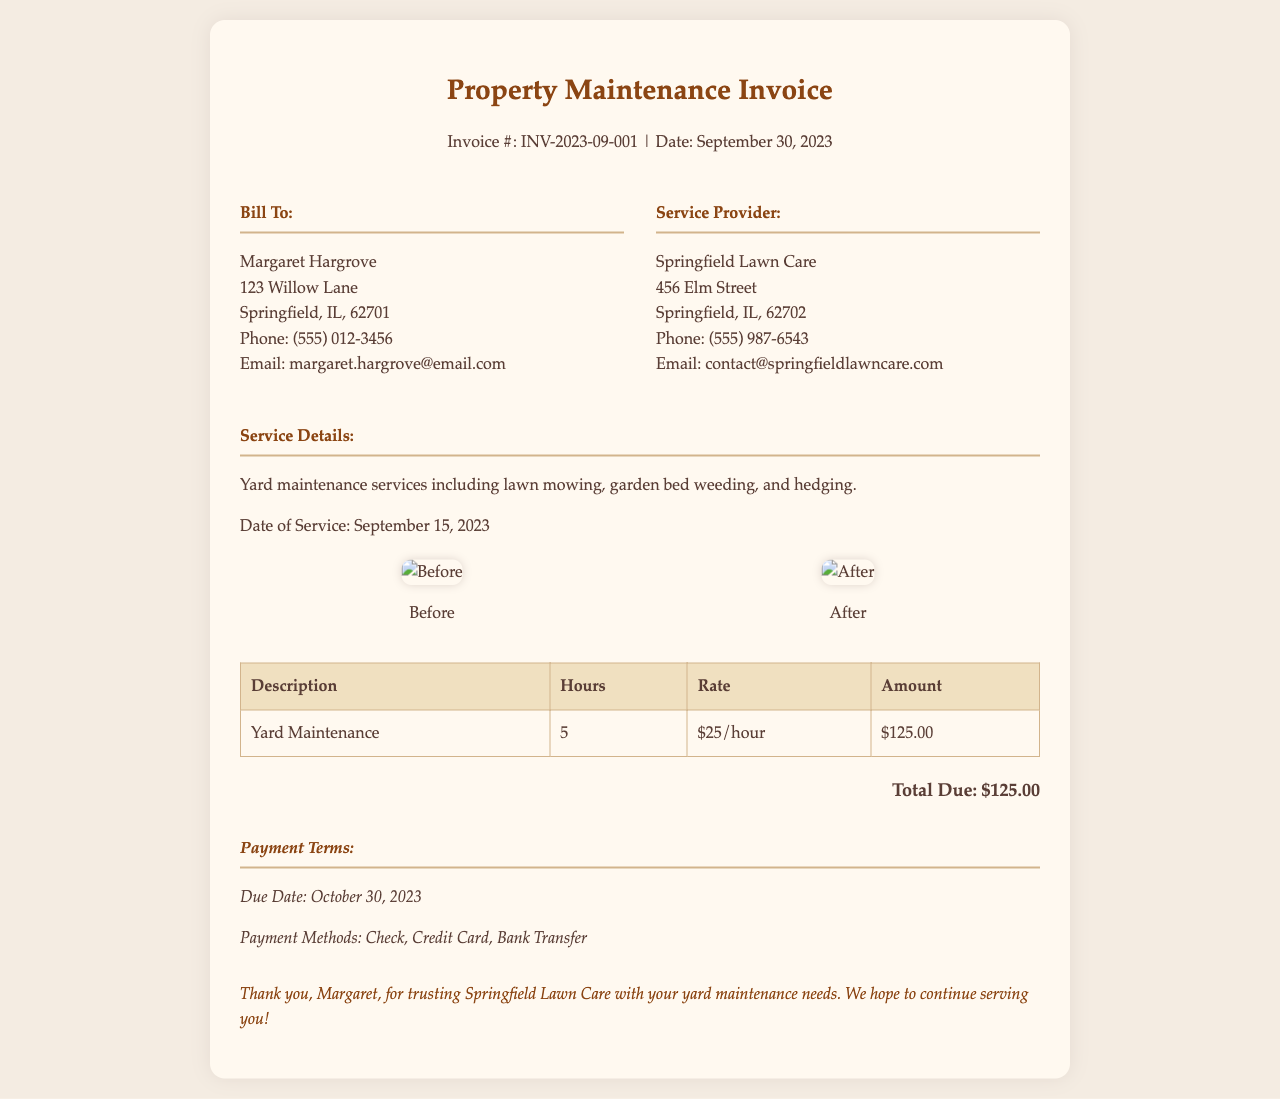What is the invoice number? The invoice number is specified in the header of the document as INV-2023-09-001.
Answer: INV-2023-09-001 What is the date of service? The date of service is mentioned under the service details section as September 15, 2023.
Answer: September 15, 2023 Who is the service provider? The service provider's name is listed in the document, which is Springfield Lawn Care.
Answer: Springfield Lawn Care What is the total due amount? The total due amount is stated towards the end of the service details section as $125.00.
Answer: $125.00 How many hours were worked for the yard maintenance? The number of hours worked for the yard maintenance is given as 5 hours in the invoice table.
Answer: 5 What type of services were performed? The services performed are specified in the service details as yard maintenance including lawn mowing, garden bed weeding, and hedging.
Answer: Yard maintenance including lawn mowing, garden bed weeding, and hedging What is the due date for payment? The due date for payment is provided in the payment terms section as October 30, 2023.
Answer: October 30, 2023 What is the hourly rate for the yard maintenance? The hourly rate for the yard maintenance is indicated in the invoice table as $25/hour.
Answer: $25/hour What is included in the payment methods? The payment methods are listed in the payment terms section, including Check, Credit Card, and Bank Transfer.
Answer: Check, Credit Card, Bank Transfer 